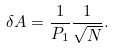Convert formula to latex. <formula><loc_0><loc_0><loc_500><loc_500>\delta A = \frac { 1 } { P _ { 1 } } \frac { 1 } { \sqrt { N } } .</formula> 